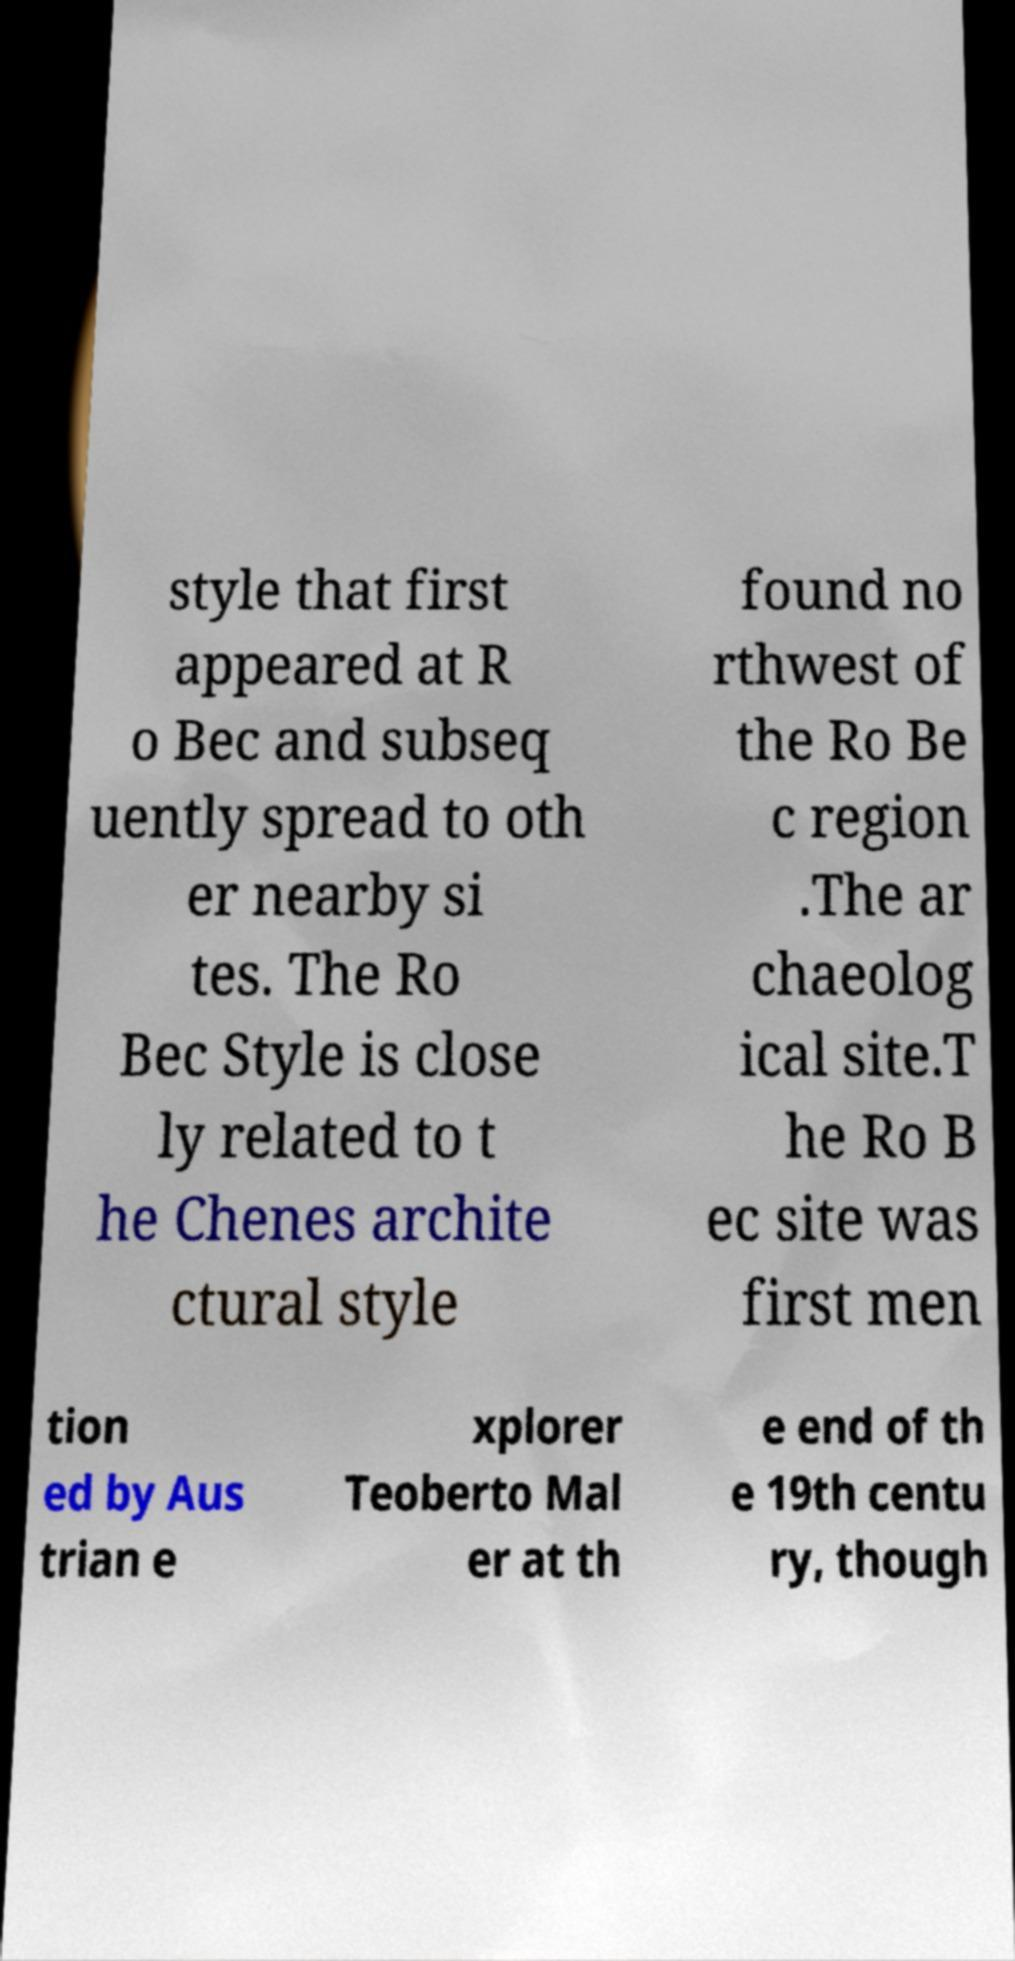Please identify and transcribe the text found in this image. style that first appeared at R o Bec and subseq uently spread to oth er nearby si tes. The Ro Bec Style is close ly related to t he Chenes archite ctural style found no rthwest of the Ro Be c region .The ar chaeolog ical site.T he Ro B ec site was first men tion ed by Aus trian e xplorer Teoberto Mal er at th e end of th e 19th centu ry, though 